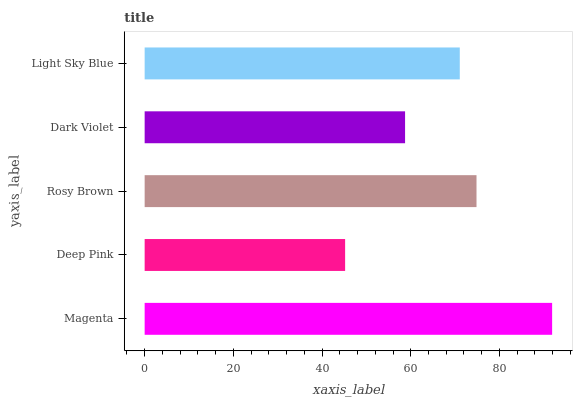Is Deep Pink the minimum?
Answer yes or no. Yes. Is Magenta the maximum?
Answer yes or no. Yes. Is Rosy Brown the minimum?
Answer yes or no. No. Is Rosy Brown the maximum?
Answer yes or no. No. Is Rosy Brown greater than Deep Pink?
Answer yes or no. Yes. Is Deep Pink less than Rosy Brown?
Answer yes or no. Yes. Is Deep Pink greater than Rosy Brown?
Answer yes or no. No. Is Rosy Brown less than Deep Pink?
Answer yes or no. No. Is Light Sky Blue the high median?
Answer yes or no. Yes. Is Light Sky Blue the low median?
Answer yes or no. Yes. Is Dark Violet the high median?
Answer yes or no. No. Is Deep Pink the low median?
Answer yes or no. No. 